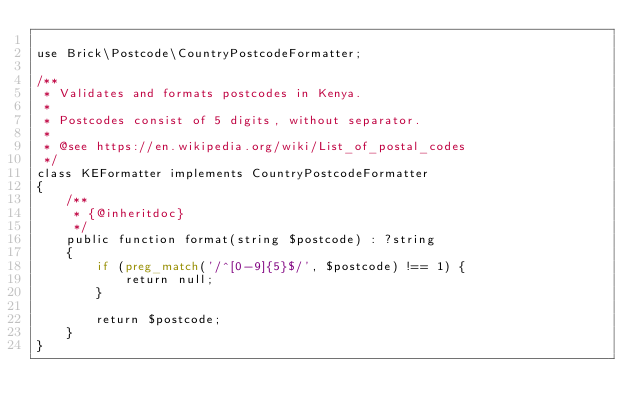Convert code to text. <code><loc_0><loc_0><loc_500><loc_500><_PHP_>
use Brick\Postcode\CountryPostcodeFormatter;

/**
 * Validates and formats postcodes in Kenya.
 *
 * Postcodes consist of 5 digits, without separator.
 *
 * @see https://en.wikipedia.org/wiki/List_of_postal_codes
 */
class KEFormatter implements CountryPostcodeFormatter
{
    /**
     * {@inheritdoc}
     */
    public function format(string $postcode) : ?string
    {
        if (preg_match('/^[0-9]{5}$/', $postcode) !== 1) {
            return null;
        }

        return $postcode;
    }
}
</code> 